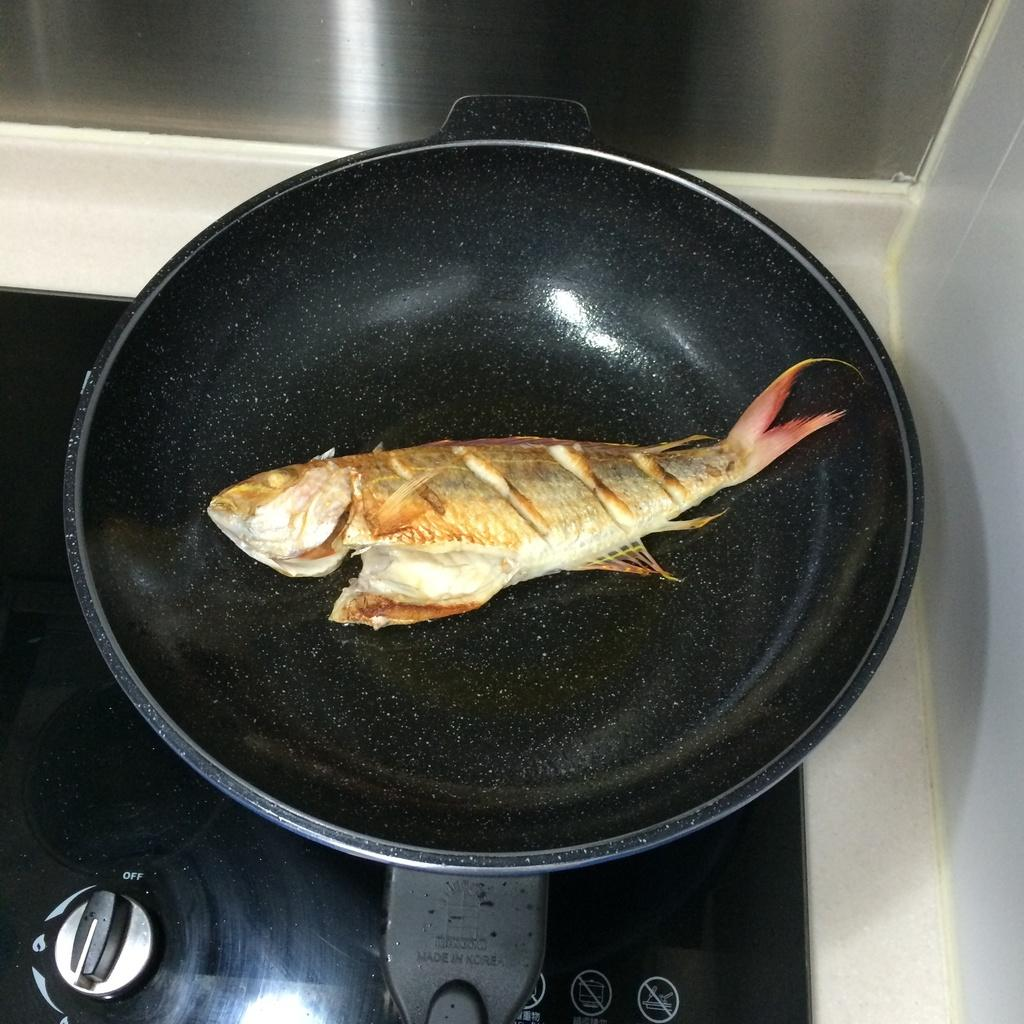What is the main subject of the image? There is a fish in the image. Where is the fish located? The fish is in a pan. What is the pan placed on? The pan is on a stove. What type of footwear is the maid wearing in the image? There is no maid or footwear present in the image; it only features a fish in a pan on a stove. 